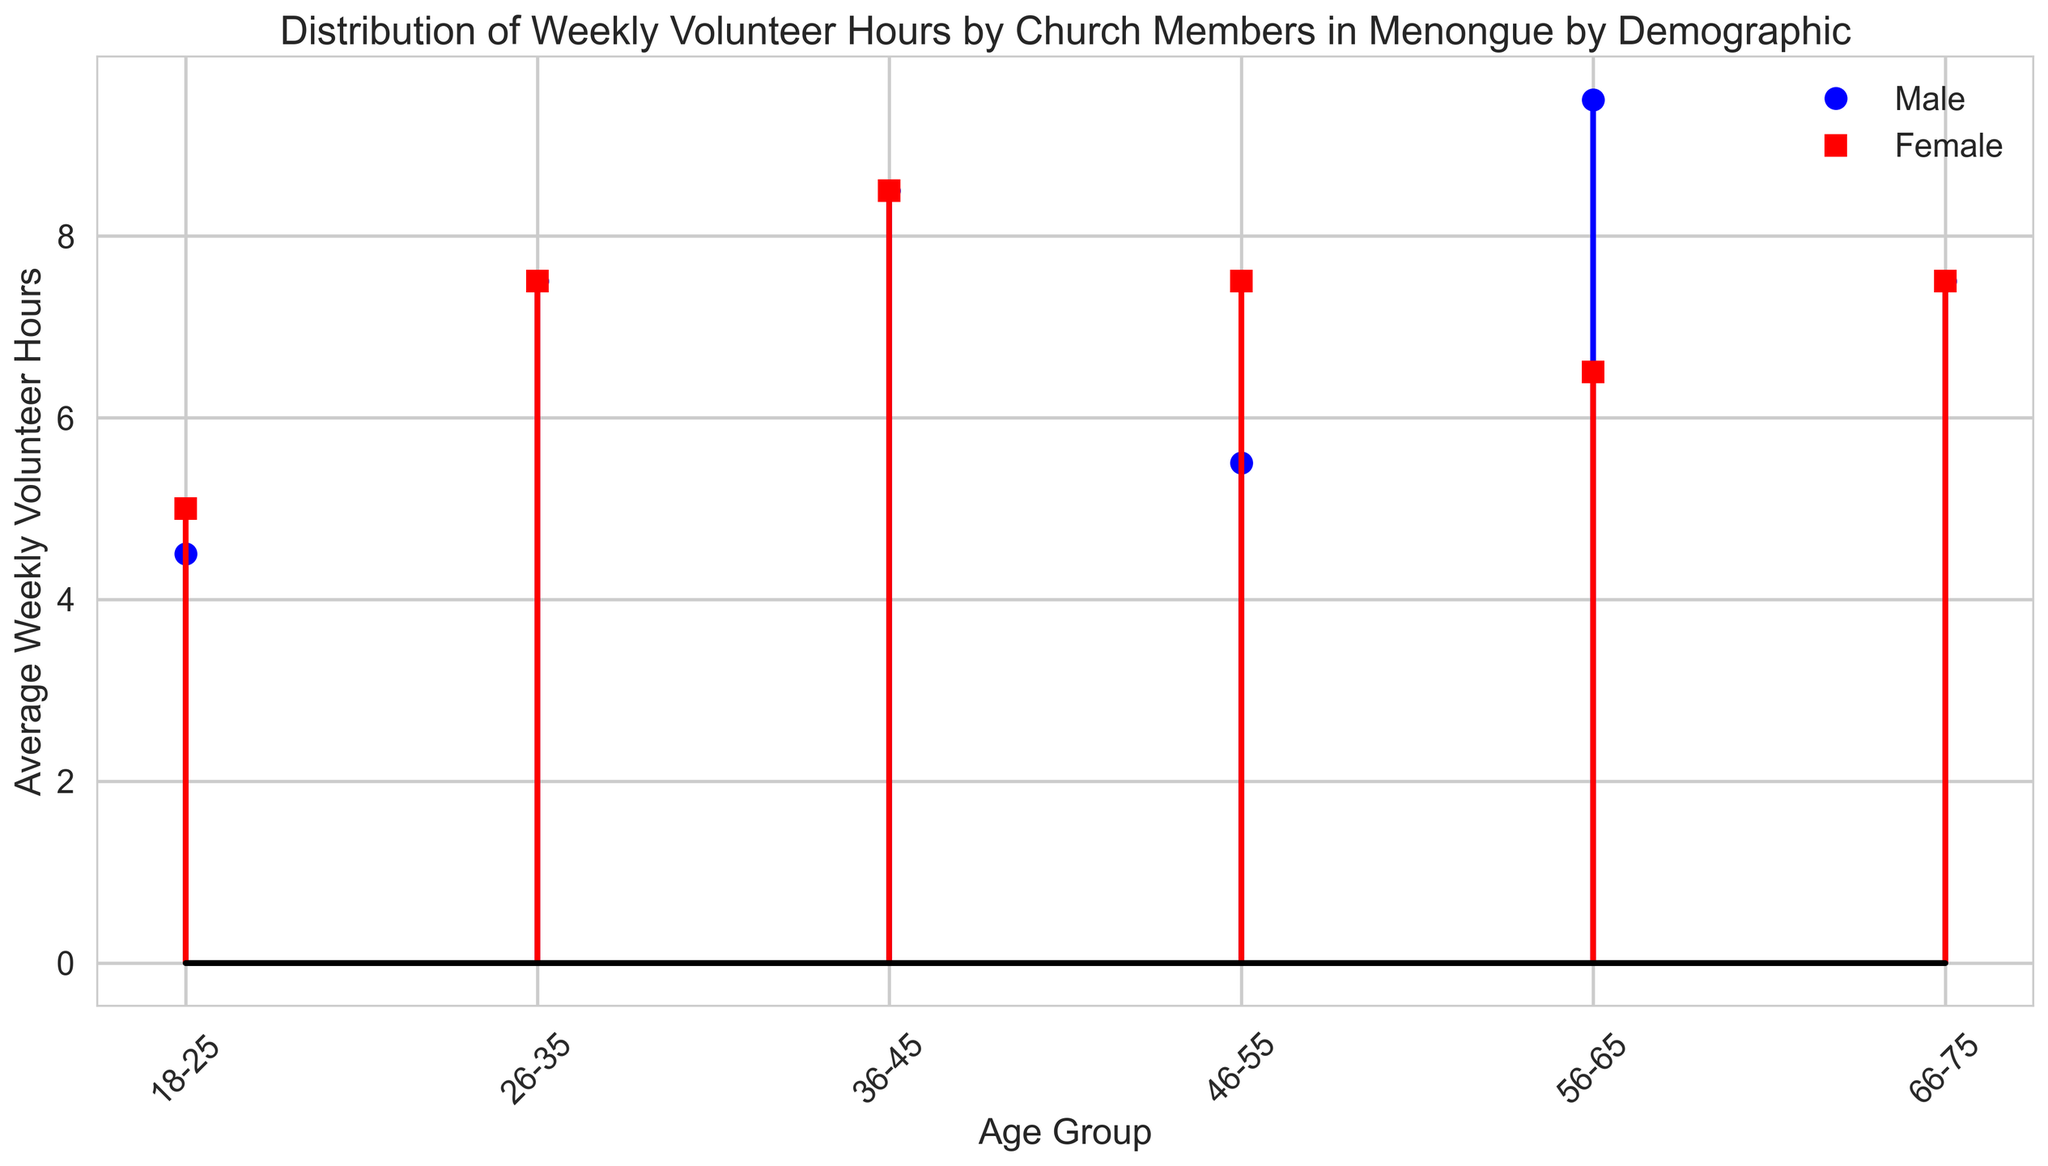What is the average weekly volunteer hours for males in the age group 18-25? Locate the stem representing males (blue circles) in the figure for the age group 18-25. Determine the average value depicted on the y-axis.
Answer: 4.5 Which age group has the highest average weekly volunteer hours for males? Identify the tallest stem among the blue circles (representing males) in the plot. The age group corresponding to the tallest stem is the one with the highest average.
Answer: 36-45 How does the average volunteer hours for females in the age group 36-45 compare to those in the age group 18-25? Locate the red squares representing the average weekly volunteer hours for females in the age groups 36-45 and 18-25. Compare their heights on the figure.
Answer: 36-45 is higher What is the difference in average weekly volunteer hours between males and females in the age group 26-35? Locate the blue circle and red square for the age group 26-35. Calculate the difference between their heights as shown on the y-axis.
Answer: 0.5 What age group has the smallest difference in volunteer hours between genders? Find the age group where the heights of the blue circle and red square are closest together by visual inspection.
Answer: 66-75 How do average volunteer hours for the gender with the most hours in the age group 56-65 compare to other age groups? Identify the gender with the most average hours in the 56-65 group by checking the tallest stem (males). Compare this height to the other age groups' tallest stems.
Answer: Highest in 56-65 What's the total average weekly volunteer hours for all demographics in the age group 46-55? Sum the average hours of both genders in the age group 46-55 by adding the heights of the blue circle and red square for this group.
Answer: 13 Which age group shows an equal average of volunteer hours for both males and females? Identify if there is any age group where the height of the blue circle and red square are exactly the same.
Answer: None What's the difference between the highest and lowest average volunteer hours for females across all age groups? Determine the highest and lowest values for red squares across all age groups and compute the difference between them.
Answer: 3 (9 - 6) In which age groups are males volunteering more hours on average than females, and by how much? For each age group, compare the heights of the blue circle and red square. List the age groups where the blue circle is higher and calculate the difference.
Answer: 56-65 by 3 